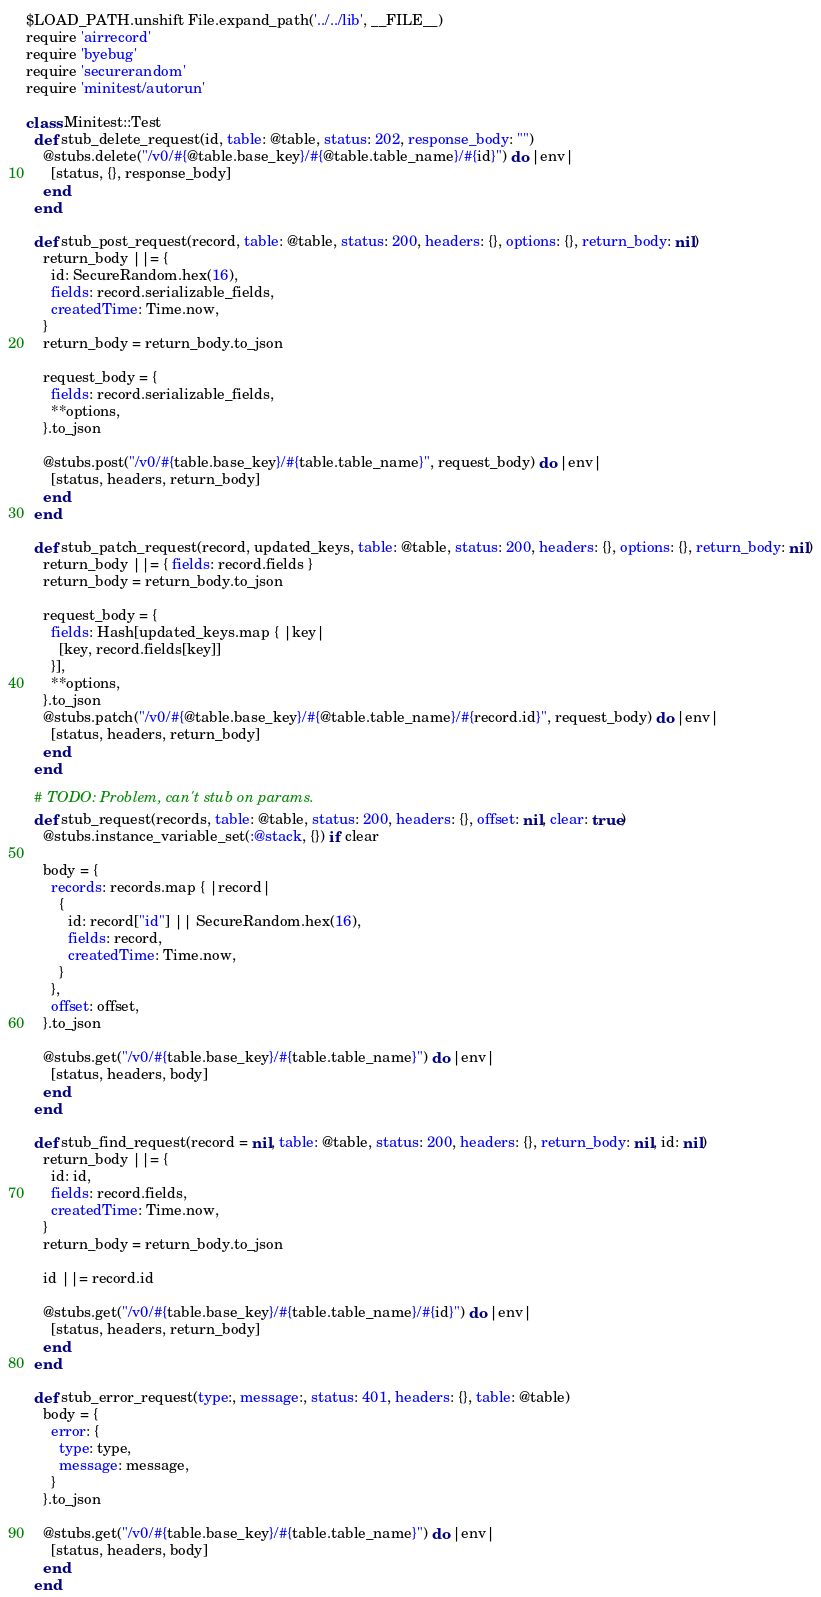<code> <loc_0><loc_0><loc_500><loc_500><_Ruby_>$LOAD_PATH.unshift File.expand_path('../../lib', __FILE__)
require 'airrecord'
require 'byebug'
require 'securerandom'
require 'minitest/autorun'

class Minitest::Test
  def stub_delete_request(id, table: @table, status: 202, response_body: "")
    @stubs.delete("/v0/#{@table.base_key}/#{@table.table_name}/#{id}") do |env|
      [status, {}, response_body]
    end
  end

  def stub_post_request(record, table: @table, status: 200, headers: {}, options: {}, return_body: nil)
    return_body ||= {
      id: SecureRandom.hex(16),
      fields: record.serializable_fields,
      createdTime: Time.now,
    }
    return_body = return_body.to_json

    request_body = {
      fields: record.serializable_fields,
      **options,
    }.to_json

    @stubs.post("/v0/#{table.base_key}/#{table.table_name}", request_body) do |env|
      [status, headers, return_body]
    end
  end

  def stub_patch_request(record, updated_keys, table: @table, status: 200, headers: {}, options: {}, return_body: nil)
    return_body ||= { fields: record.fields }
    return_body = return_body.to_json

    request_body = {
      fields: Hash[updated_keys.map { |key|
        [key, record.fields[key]]
      }],
      **options,
    }.to_json
    @stubs.patch("/v0/#{@table.base_key}/#{@table.table_name}/#{record.id}", request_body) do |env|
      [status, headers, return_body]
    end
  end

  # TODO: Problem, can't stub on params.
  def stub_request(records, table: @table, status: 200, headers: {}, offset: nil, clear: true)
    @stubs.instance_variable_set(:@stack, {}) if clear

    body = {
      records: records.map { |record|
        {
          id: record["id"] || SecureRandom.hex(16),
          fields: record,
          createdTime: Time.now,
        }
      },
      offset: offset,
    }.to_json

    @stubs.get("/v0/#{table.base_key}/#{table.table_name}") do |env|
      [status, headers, body]
    end
  end

  def stub_find_request(record = nil, table: @table, status: 200, headers: {}, return_body: nil, id: nil)
    return_body ||= {
      id: id,
      fields: record.fields,
      createdTime: Time.now,
    }
    return_body = return_body.to_json

    id ||= record.id

    @stubs.get("/v0/#{table.base_key}/#{table.table_name}/#{id}") do |env|
      [status, headers, return_body]
    end
  end

  def stub_error_request(type:, message:, status: 401, headers: {}, table: @table)
    body = {
      error: {
        type: type,
        message: message,
      }
    }.to_json

    @stubs.get("/v0/#{table.base_key}/#{table.table_name}") do |env|
      [status, headers, body]
    end
  end
</code> 